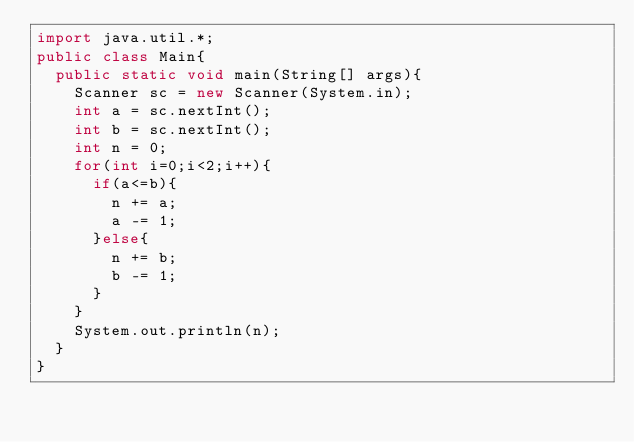Convert code to text. <code><loc_0><loc_0><loc_500><loc_500><_Java_>import java.util.*;
public class Main{
  public static void main(String[] args){
    Scanner sc = new Scanner(System.in);
    int a = sc.nextInt();
    int b = sc.nextInt();
    int n = 0;
    for(int i=0;i<2;i++){
      if(a<=b){
        n += a;
        a -= 1;
      }else{
        n += b;
        b -= 1;
      }
    } 
    System.out.println(n);
  }
}








</code> 